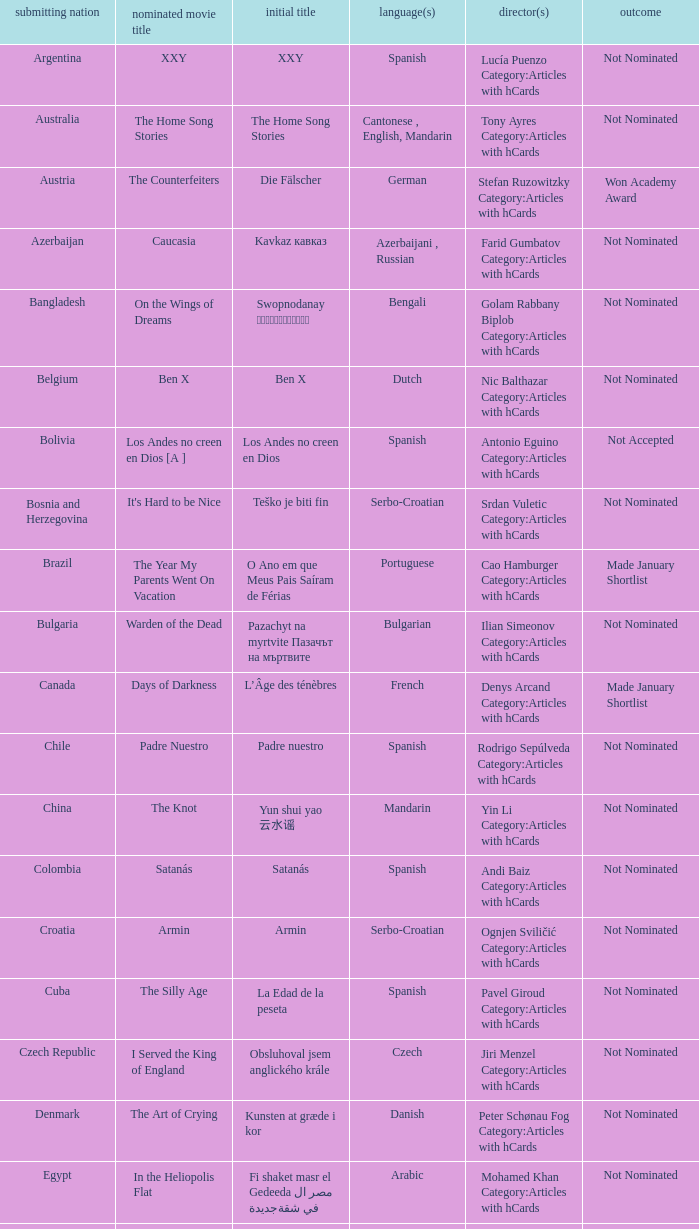What country submitted miehen työ? Finland. 